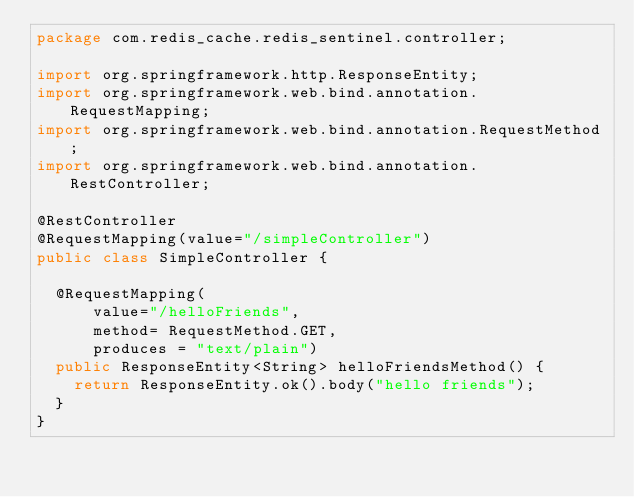Convert code to text. <code><loc_0><loc_0><loc_500><loc_500><_Java_>package com.redis_cache.redis_sentinel.controller;

import org.springframework.http.ResponseEntity;
import org.springframework.web.bind.annotation.RequestMapping;
import org.springframework.web.bind.annotation.RequestMethod;
import org.springframework.web.bind.annotation.RestController;

@RestController
@RequestMapping(value="/simpleController")
public class SimpleController {

	@RequestMapping(
			value="/helloFriends",
			method= RequestMethod.GET,
			produces = "text/plain")
	public ResponseEntity<String> helloFriendsMethod() {
		return ResponseEntity.ok().body("hello friends");
	}
}
</code> 